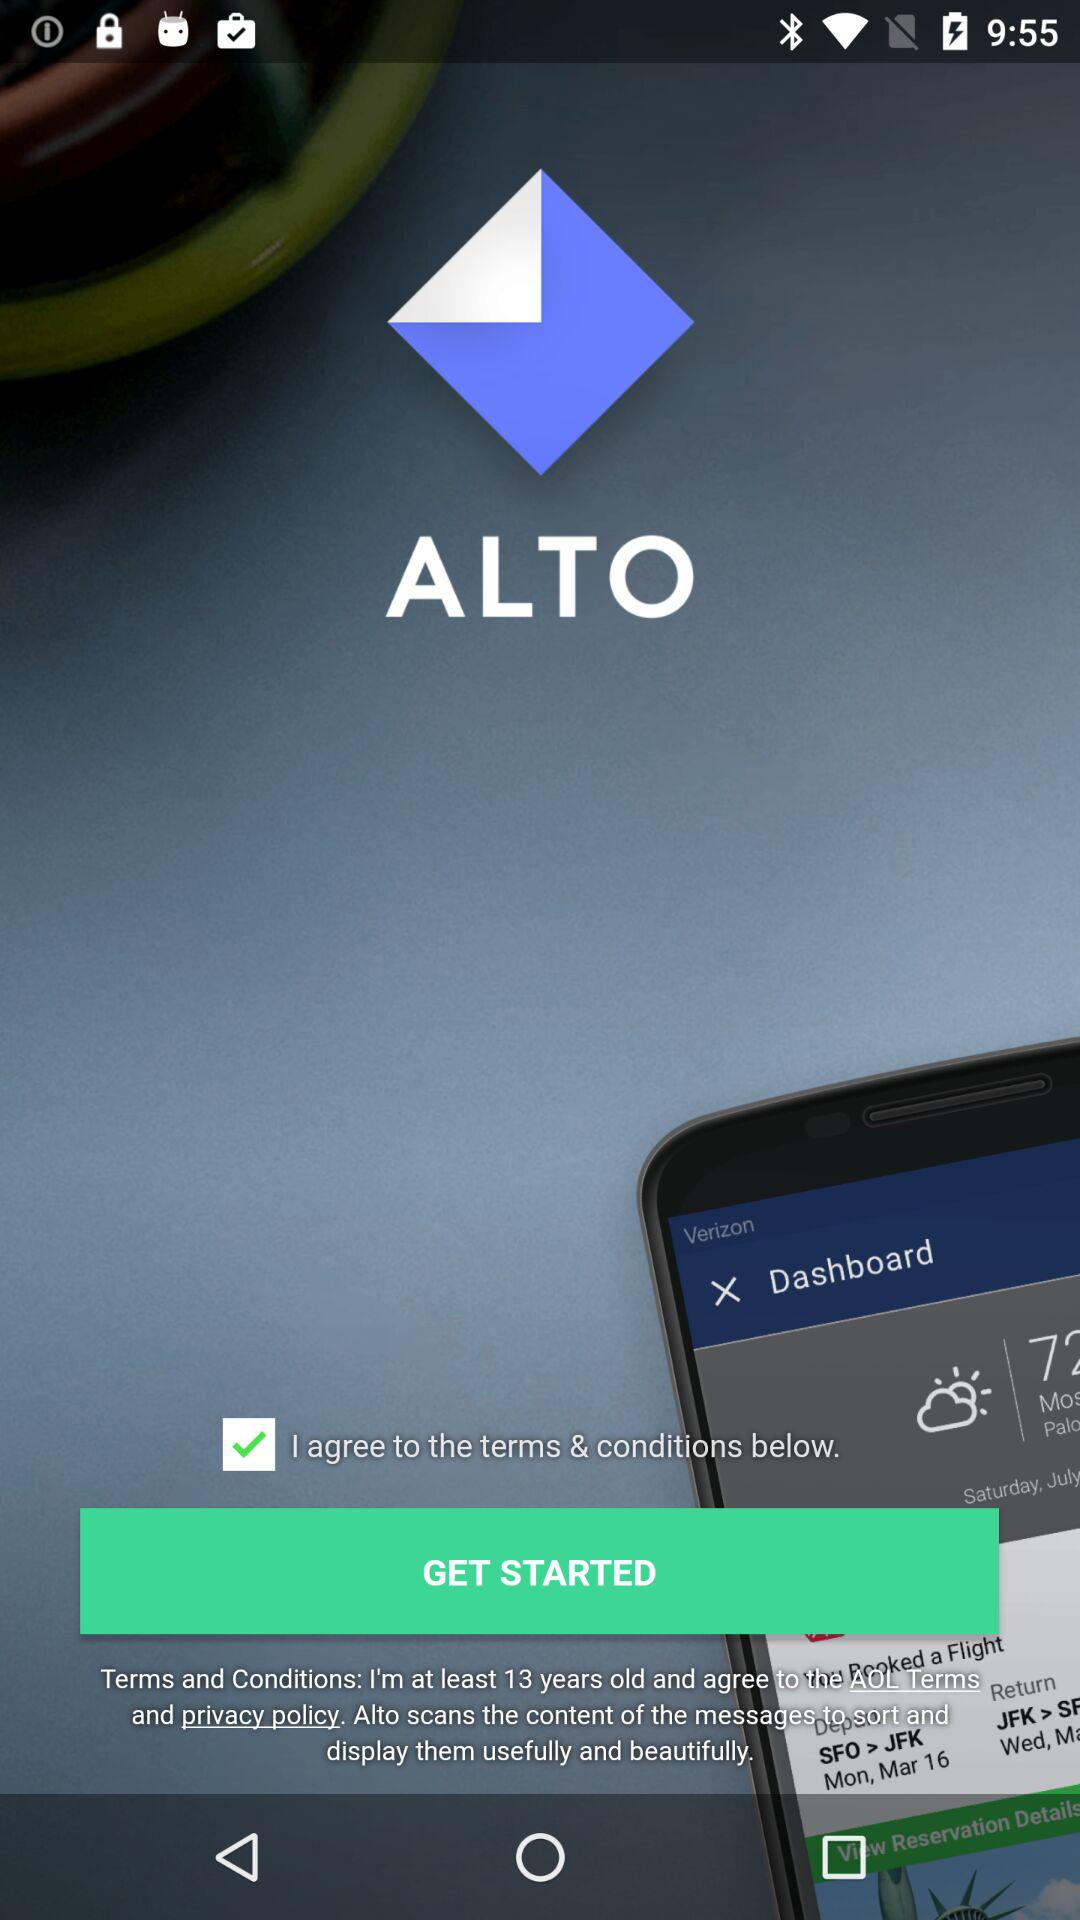How old is the user?
When the provided information is insufficient, respond with <no answer>. <no answer> 